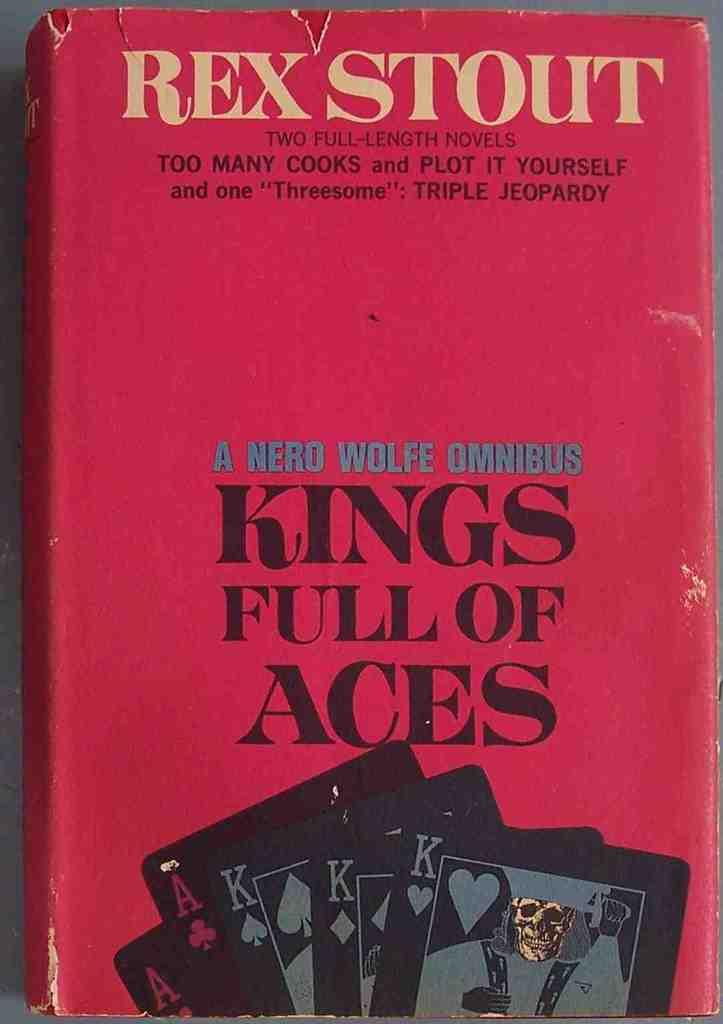What is the main subject of the image? The main subject of the image is the cover page of a book. What can be found on the cover page? There is text and images on the cover page. What type of paper is used to create the feeling of the book cover in the image? There is no mention of the type of paper used or any feelings associated with the book cover in the image. 